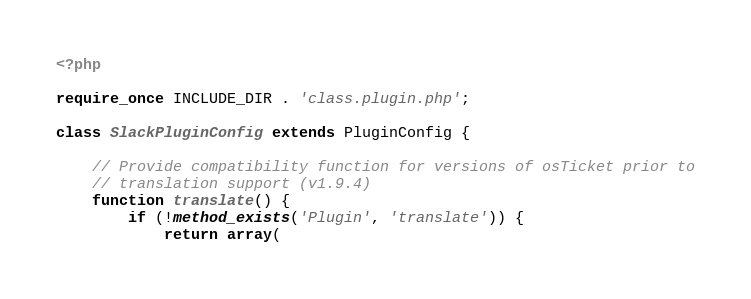Convert code to text. <code><loc_0><loc_0><loc_500><loc_500><_PHP_><?php

require_once INCLUDE_DIR . 'class.plugin.php';

class SlackPluginConfig extends PluginConfig {

    // Provide compatibility function for versions of osTicket prior to
    // translation support (v1.9.4)
    function translate() {
        if (!method_exists('Plugin', 'translate')) {
            return array(</code> 